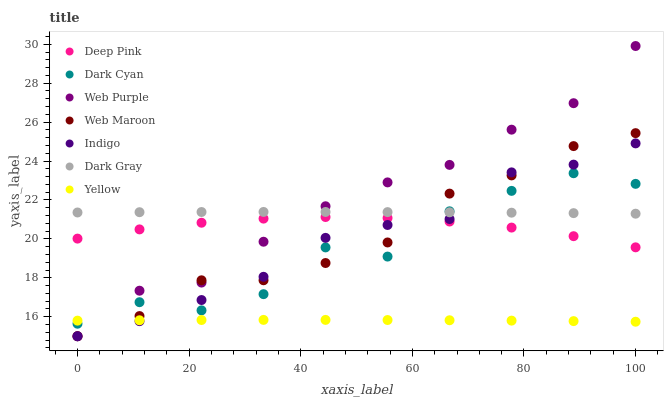Does Yellow have the minimum area under the curve?
Answer yes or no. Yes. Does Web Purple have the maximum area under the curve?
Answer yes or no. Yes. Does Indigo have the minimum area under the curve?
Answer yes or no. No. Does Indigo have the maximum area under the curve?
Answer yes or no. No. Is Dark Gray the smoothest?
Answer yes or no. Yes. Is Dark Cyan the roughest?
Answer yes or no. Yes. Is Indigo the smoothest?
Answer yes or no. No. Is Indigo the roughest?
Answer yes or no. No. Does Indigo have the lowest value?
Answer yes or no. Yes. Does Yellow have the lowest value?
Answer yes or no. No. Does Web Purple have the highest value?
Answer yes or no. Yes. Does Indigo have the highest value?
Answer yes or no. No. Is Yellow less than Dark Gray?
Answer yes or no. Yes. Is Deep Pink greater than Yellow?
Answer yes or no. Yes. Does Dark Gray intersect Indigo?
Answer yes or no. Yes. Is Dark Gray less than Indigo?
Answer yes or no. No. Is Dark Gray greater than Indigo?
Answer yes or no. No. Does Yellow intersect Dark Gray?
Answer yes or no. No. 